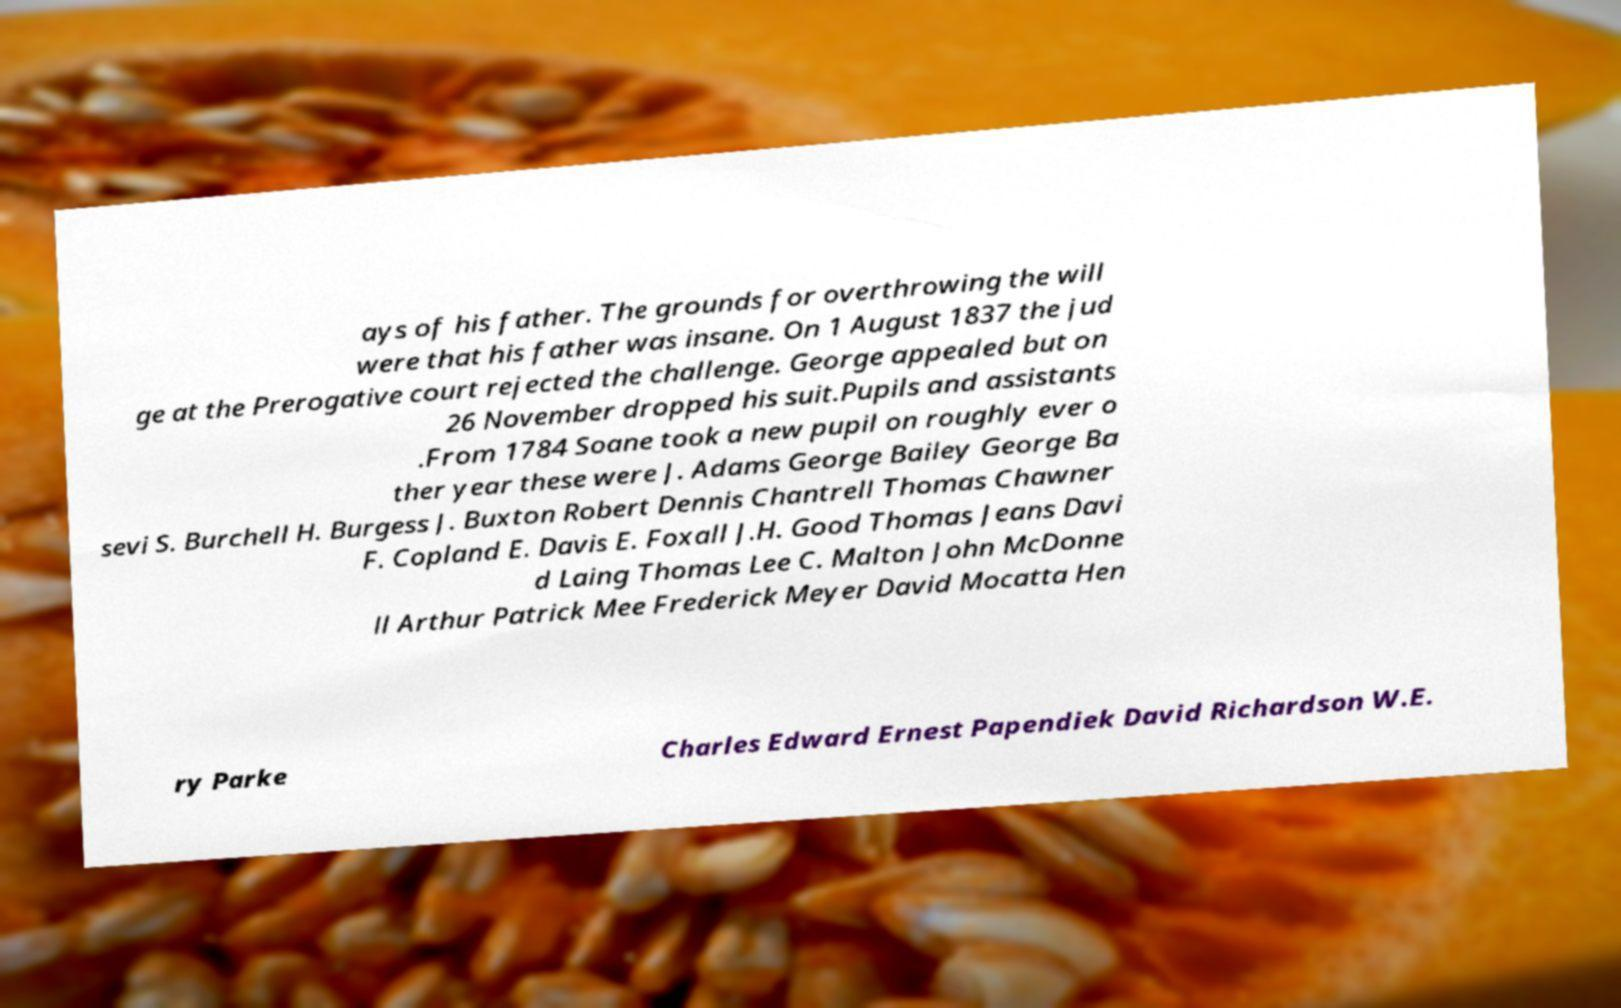Could you assist in decoding the text presented in this image and type it out clearly? ays of his father. The grounds for overthrowing the will were that his father was insane. On 1 August 1837 the jud ge at the Prerogative court rejected the challenge. George appealed but on 26 November dropped his suit.Pupils and assistants .From 1784 Soane took a new pupil on roughly ever o ther year these were J. Adams George Bailey George Ba sevi S. Burchell H. Burgess J. Buxton Robert Dennis Chantrell Thomas Chawner F. Copland E. Davis E. Foxall J.H. Good Thomas Jeans Davi d Laing Thomas Lee C. Malton John McDonne ll Arthur Patrick Mee Frederick Meyer David Mocatta Hen ry Parke Charles Edward Ernest Papendiek David Richardson W.E. 